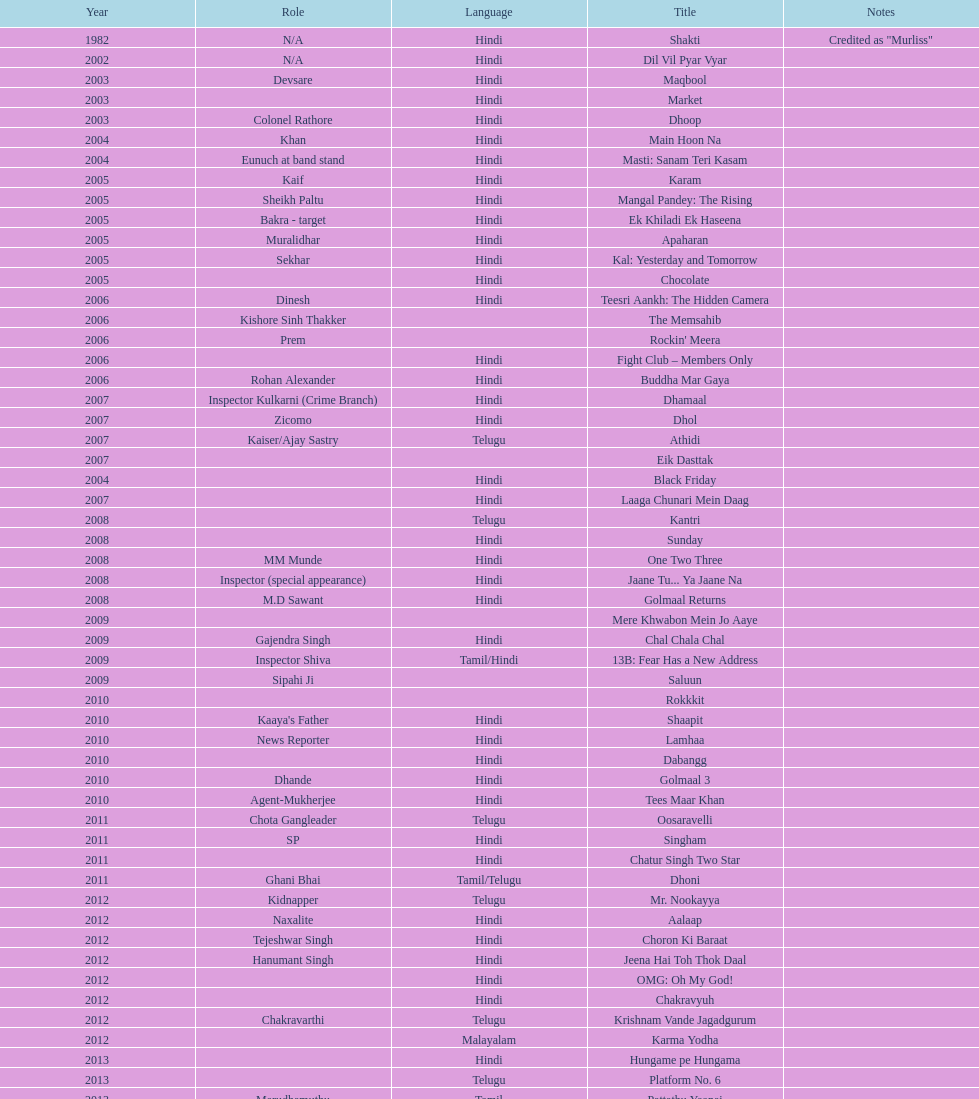What title is before dhol in 2007? Dhamaal. 